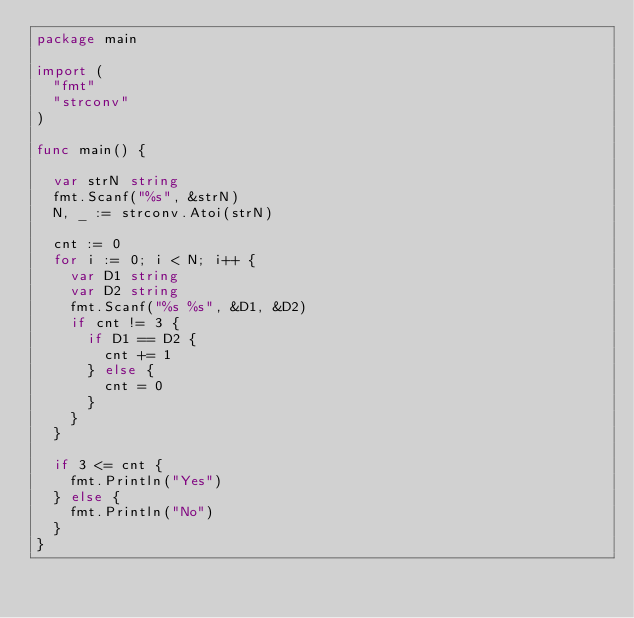<code> <loc_0><loc_0><loc_500><loc_500><_Go_>package main

import (
	"fmt"
	"strconv"
)

func main() {

	var strN string
	fmt.Scanf("%s", &strN)
	N, _ := strconv.Atoi(strN)

	cnt := 0
	for i := 0; i < N; i++ {
		var D1 string
		var D2 string
		fmt.Scanf("%s %s", &D1, &D2)
		if cnt != 3 {
			if D1 == D2 {
				cnt += 1
			} else {
				cnt = 0
			}
		}
	}

	if 3 <= cnt {
		fmt.Println("Yes")
	} else {
		fmt.Println("No")
	}
}
</code> 